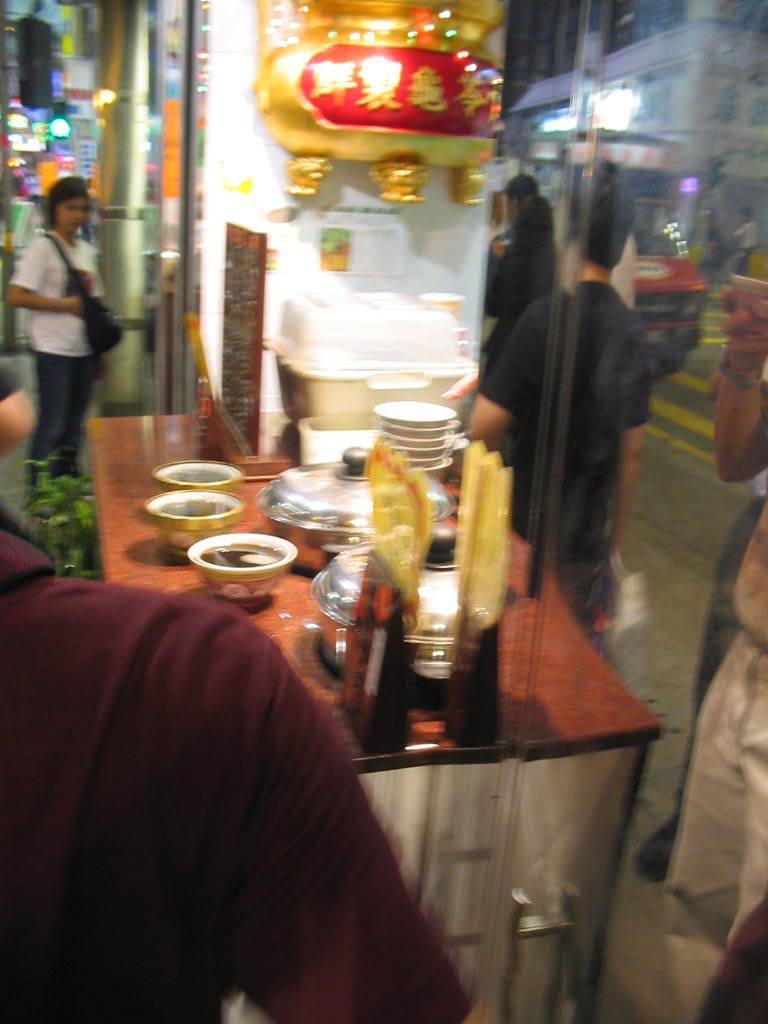Could you give a brief overview of what you see in this image? In this image I can see few people, lights and the glass wall. In front I can see few bowls, vessels and few objects on the table. I can see the gold and red color object is attached to the wall. 